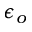<formula> <loc_0><loc_0><loc_500><loc_500>\epsilon _ { o }</formula> 